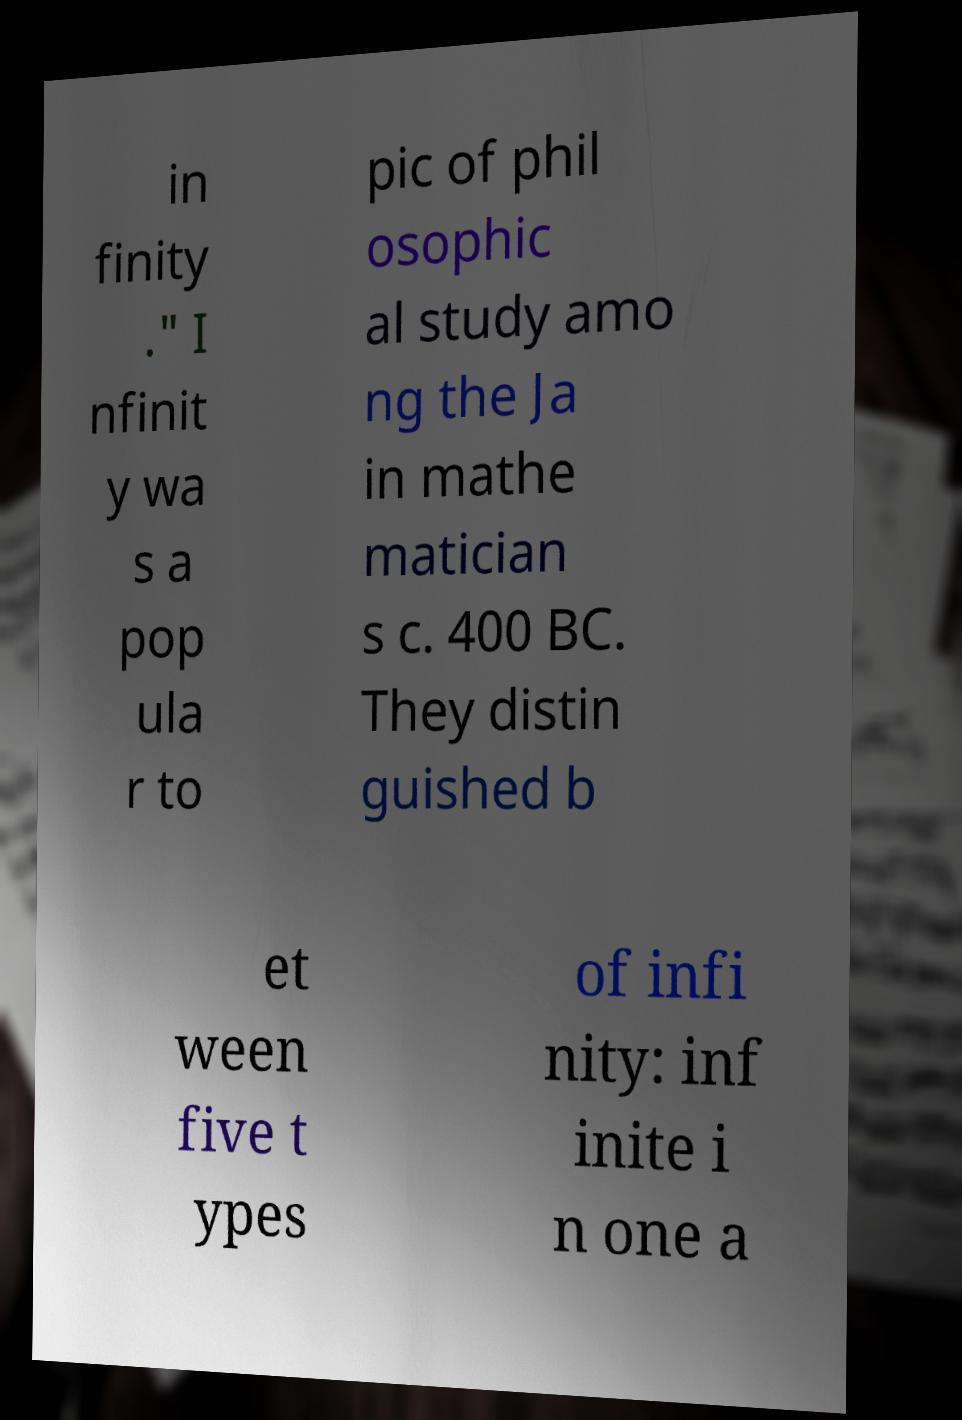Can you read and provide the text displayed in the image?This photo seems to have some interesting text. Can you extract and type it out for me? in finity ." I nfinit y wa s a pop ula r to pic of phil osophic al study amo ng the Ja in mathe matician s c. 400 BC. They distin guished b et ween five t ypes of infi nity: inf inite i n one a 